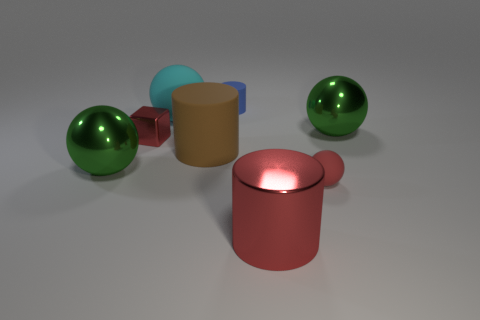Subtract all big balls. How many balls are left? 1 Add 1 green objects. How many objects exist? 9 Subtract 1 cylinders. How many cylinders are left? 2 Subtract all cyan spheres. How many spheres are left? 3 Subtract all cylinders. How many objects are left? 5 Subtract all cyan spheres. Subtract all red cylinders. How many spheres are left? 3 Subtract all red blocks. Subtract all big brown rubber objects. How many objects are left? 6 Add 5 large matte cylinders. How many large matte cylinders are left? 6 Add 5 yellow rubber cylinders. How many yellow rubber cylinders exist? 5 Subtract 1 red cylinders. How many objects are left? 7 